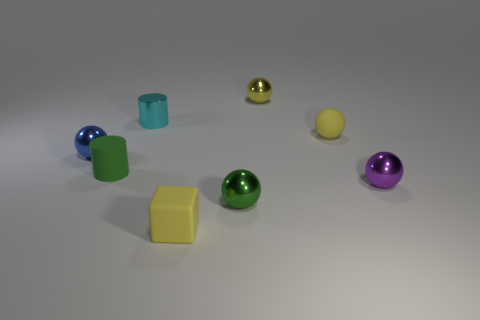Subtract all small blue spheres. How many spheres are left? 4 Add 1 matte objects. How many objects exist? 9 Subtract all green spheres. How many spheres are left? 4 Subtract 0 gray balls. How many objects are left? 8 Subtract all cubes. How many objects are left? 7 Subtract 3 spheres. How many spheres are left? 2 Subtract all gray cylinders. Subtract all gray cubes. How many cylinders are left? 2 Subtract all blue cylinders. How many green spheres are left? 1 Subtract all large red cylinders. Subtract all small yellow things. How many objects are left? 5 Add 3 small shiny cylinders. How many small shiny cylinders are left? 4 